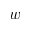<formula> <loc_0><loc_0><loc_500><loc_500>w</formula> 